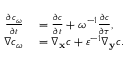<formula> <loc_0><loc_0><loc_500><loc_500>\begin{array} { r l } { \frac { \partial c _ { \omega } } { \partial t } } & = \frac { \partial c } { \partial t } + \omega ^ { - 1 } \frac { \partial c } { \partial \tau } , } \\ { \nabla c _ { \omega } } & = \nabla _ { \mathbf x } c + \varepsilon ^ { - 1 } \nabla _ { \mathbf y } c . } \end{array}</formula> 